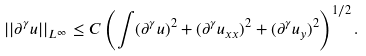<formula> <loc_0><loc_0><loc_500><loc_500>| | \partial ^ { \gamma } u | | _ { L ^ { \infty } } \leq C \left ( \int ( \partial ^ { \gamma } u ) ^ { 2 } + ( \partial ^ { \gamma } u _ { x x } ) ^ { 2 } + ( \partial ^ { \gamma } u _ { y } ) ^ { 2 } \right ) ^ { 1 / 2 } .</formula> 